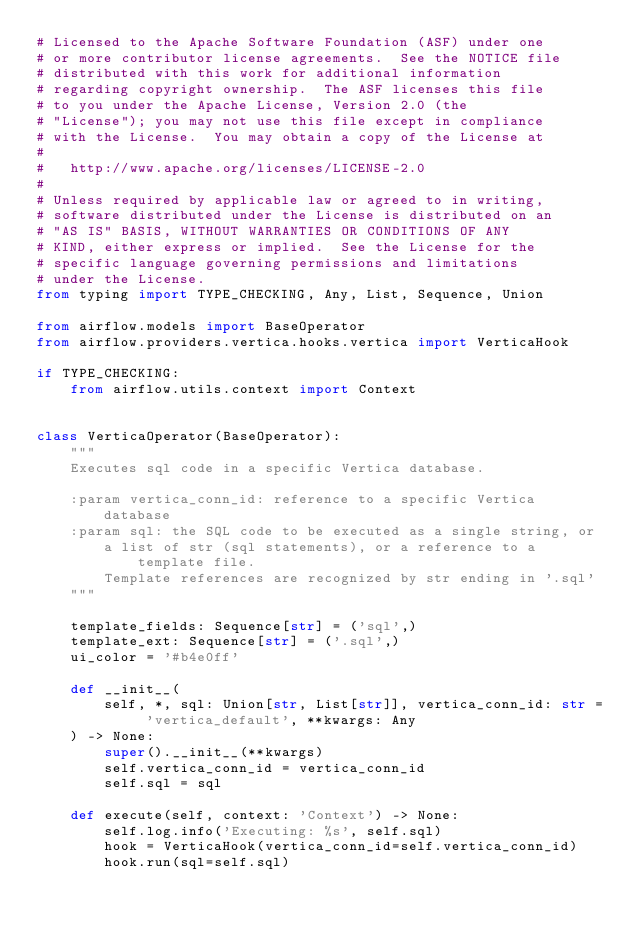Convert code to text. <code><loc_0><loc_0><loc_500><loc_500><_Python_># Licensed to the Apache Software Foundation (ASF) under one
# or more contributor license agreements.  See the NOTICE file
# distributed with this work for additional information
# regarding copyright ownership.  The ASF licenses this file
# to you under the Apache License, Version 2.0 (the
# "License"); you may not use this file except in compliance
# with the License.  You may obtain a copy of the License at
#
#   http://www.apache.org/licenses/LICENSE-2.0
#
# Unless required by applicable law or agreed to in writing,
# software distributed under the License is distributed on an
# "AS IS" BASIS, WITHOUT WARRANTIES OR CONDITIONS OF ANY
# KIND, either express or implied.  See the License for the
# specific language governing permissions and limitations
# under the License.
from typing import TYPE_CHECKING, Any, List, Sequence, Union

from airflow.models import BaseOperator
from airflow.providers.vertica.hooks.vertica import VerticaHook

if TYPE_CHECKING:
    from airflow.utils.context import Context


class VerticaOperator(BaseOperator):
    """
    Executes sql code in a specific Vertica database.

    :param vertica_conn_id: reference to a specific Vertica database
    :param sql: the SQL code to be executed as a single string, or
        a list of str (sql statements), or a reference to a template file.
        Template references are recognized by str ending in '.sql'
    """

    template_fields: Sequence[str] = ('sql',)
    template_ext: Sequence[str] = ('.sql',)
    ui_color = '#b4e0ff'

    def __init__(
        self, *, sql: Union[str, List[str]], vertica_conn_id: str = 'vertica_default', **kwargs: Any
    ) -> None:
        super().__init__(**kwargs)
        self.vertica_conn_id = vertica_conn_id
        self.sql = sql

    def execute(self, context: 'Context') -> None:
        self.log.info('Executing: %s', self.sql)
        hook = VerticaHook(vertica_conn_id=self.vertica_conn_id)
        hook.run(sql=self.sql)
</code> 